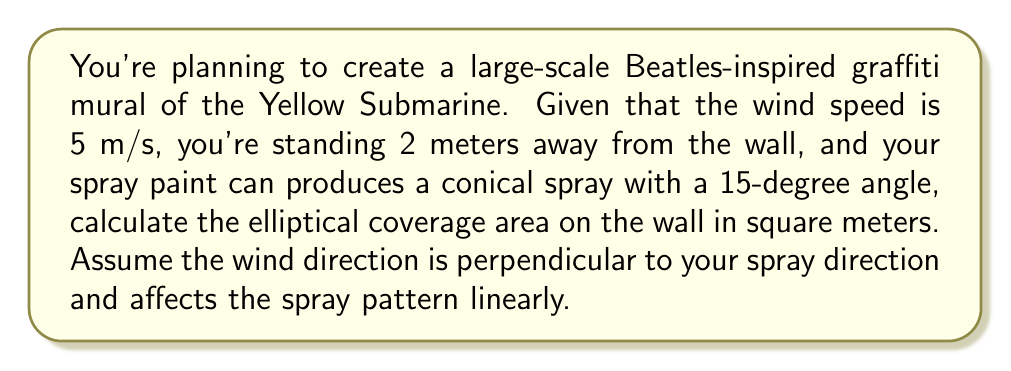Give your solution to this math problem. To solve this problem, we need to follow these steps:

1) First, let's calculate the radius of the circular spray pattern without wind:
   $r = 2 \tan(15°) = 2 \cdot 0.2679 = 0.5358$ m

2) Now, we need to account for the wind effect. The wind will elongate the spray pattern in one direction. Let's assume the wind effect is proportional to the wind speed and distance:
   Wind effect = Wind speed * Distance / 10 (assuming a linear relationship)
   $e = 5 \cdot 2 / 10 = 1$ m

3) The spray pattern will now be an ellipse. The minor axis will remain the same as the original diameter:
   $b = 2r = 2 \cdot 0.5358 = 1.0716$ m

4) The major axis will be the original diameter plus the wind effect:
   $a = 2r + e = 1.0716 + 1 = 2.0716$ m

5) The area of an ellipse is given by the formula:
   $A = \pi ab$

   Where $a$ is half the length of the major axis and $b$ is half the length of the minor axis.

6) Substituting our values:
   $A = \pi \cdot (2.0716/2) \cdot (1.0716/2)$
   $A = \pi \cdot 1.0358 \cdot 0.5358$
   $A = 1.7397$ m²

Therefore, the elliptical coverage area on the wall will be approximately 1.7397 square meters.
Answer: $1.7397$ m² 